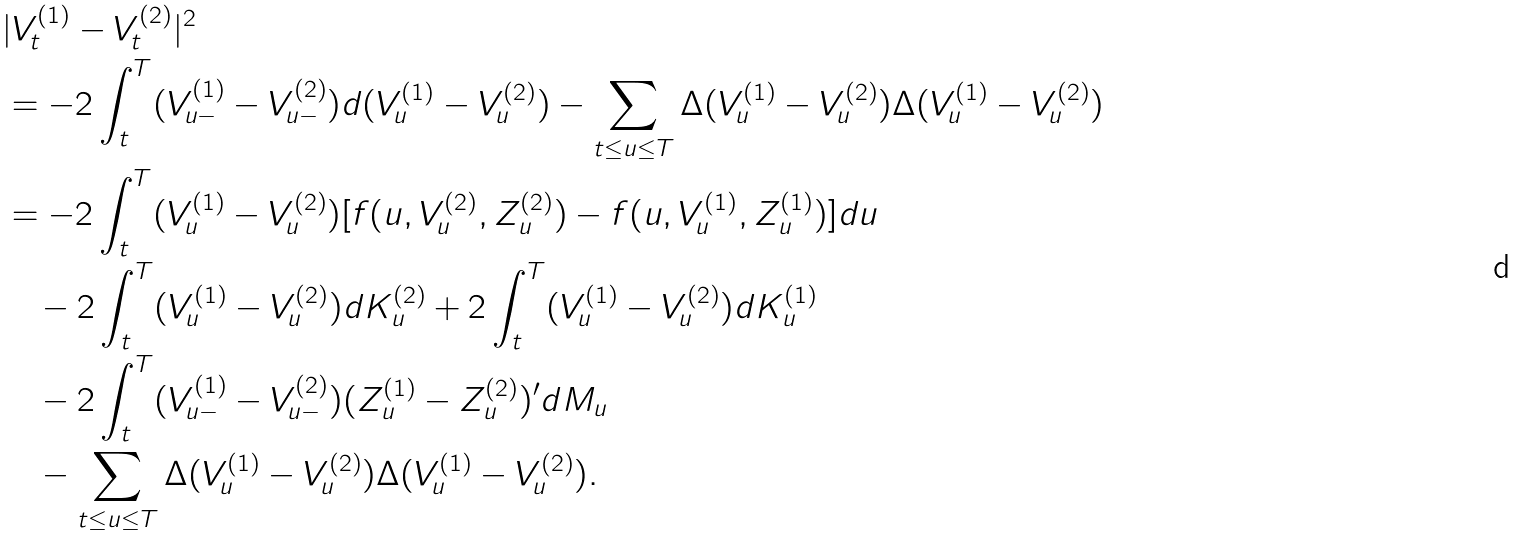Convert formula to latex. <formula><loc_0><loc_0><loc_500><loc_500>& | V _ { t } ^ { ( 1 ) } - V _ { t } ^ { ( 2 ) } | ^ { 2 } \\ & = - 2 \int _ { t } ^ { T } ( V _ { u - } ^ { ( 1 ) } - V _ { u - } ^ { ( 2 ) } ) d ( V _ { u } ^ { ( 1 ) } - V _ { u } ^ { ( 2 ) } ) - \sum _ { t \leq u \leq T } \Delta ( V _ { u } ^ { ( 1 ) } - V _ { u } ^ { ( 2 ) } ) \Delta ( V _ { u } ^ { ( 1 ) } - V _ { u } ^ { ( 2 ) } ) \\ & = - 2 \int _ { t } ^ { T } ( V ^ { ( 1 ) } _ { u } - V _ { u } ^ { ( 2 ) } ) [ f ( u , V _ { u } ^ { ( 2 ) } , Z _ { u } ^ { ( 2 ) } ) - f ( u , V _ { u } ^ { ( 1 ) } , Z _ { u } ^ { ( 1 ) } ) ] d u \\ & \quad - 2 \int _ { t } ^ { T } ( V ^ { ( 1 ) } _ { u } - V _ { u } ^ { ( 2 ) } ) d K _ { u } ^ { ( 2 ) } + 2 \int _ { t } ^ { T } ( V ^ { ( 1 ) } _ { u } - V _ { u } ^ { ( 2 ) } ) d K _ { u } ^ { ( 1 ) } \\ & \quad - 2 \int _ { t } ^ { T } ( V ^ { ( 1 ) } _ { u - } - V _ { u - } ^ { ( 2 ) } ) ( Z _ { u } ^ { ( 1 ) } - Z _ { u } ^ { ( 2 ) } ) ^ { \prime } d M _ { u } \\ & \quad - \sum _ { t \leq u \leq T } \Delta ( V _ { u } ^ { ( 1 ) } - V _ { u } ^ { ( 2 ) } ) \Delta ( V _ { u } ^ { ( 1 ) } - V _ { u } ^ { ( 2 ) } ) .</formula> 